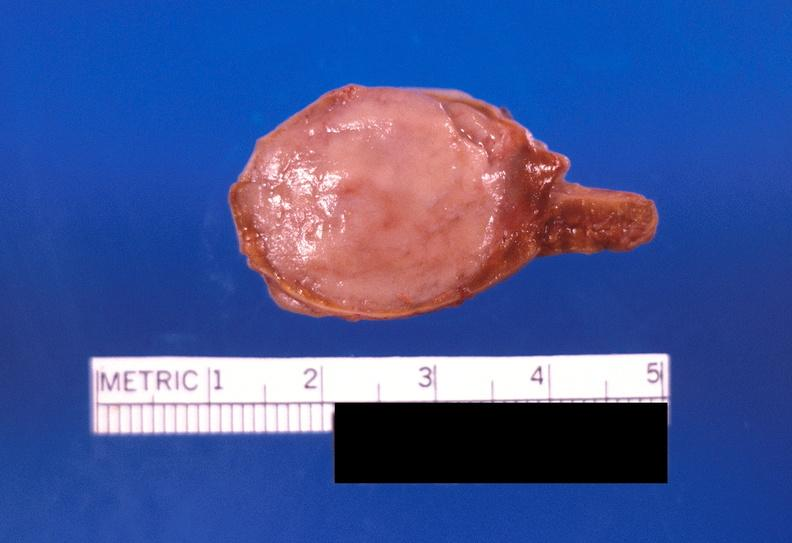what does this image show?
Answer the question using a single word or phrase. Adrenal medullary tumor 